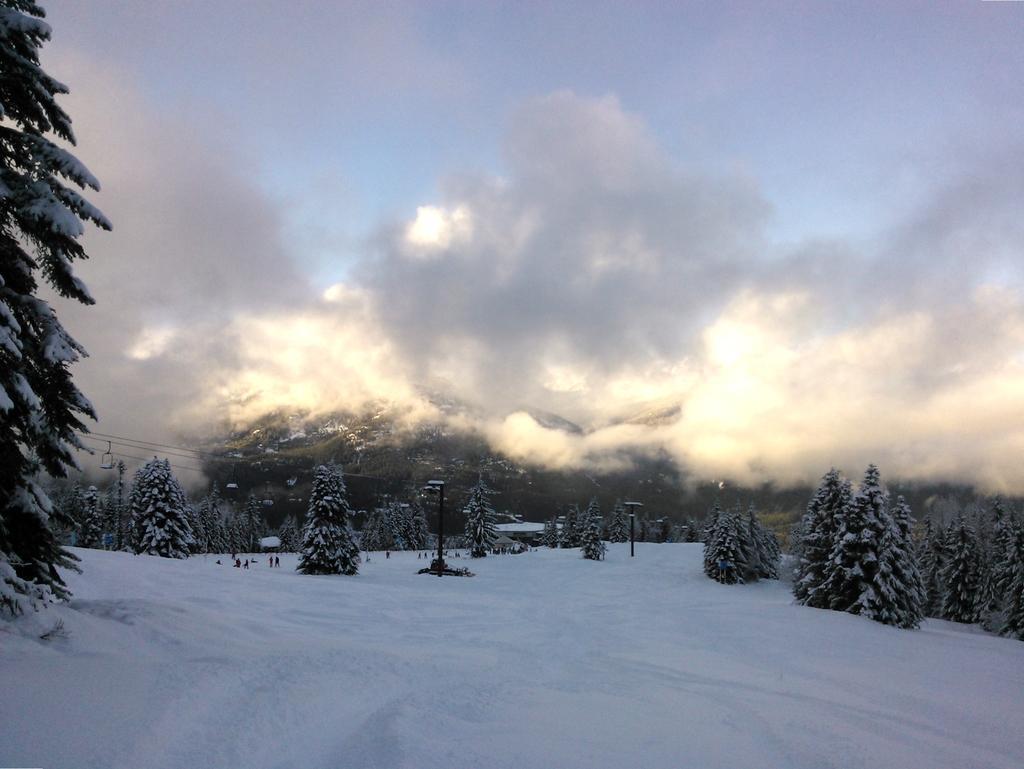Can you describe this image briefly? This is an outside view. At the bottom, I can see the snow. In the background there are many trees covered with the snow. At the top of the image I can see the sky and clouds. 